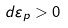<formula> <loc_0><loc_0><loc_500><loc_500>d { \varepsilon } _ { p } > 0</formula> 